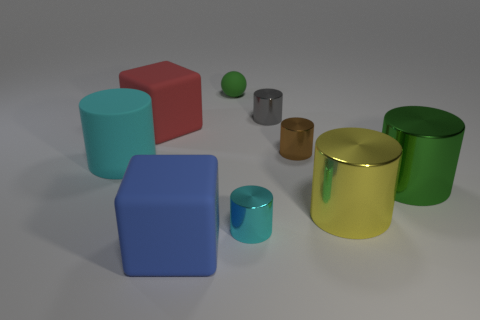Subtract all large green shiny cylinders. How many cylinders are left? 5 Subtract all red spheres. How many cyan cylinders are left? 2 Subtract all yellow cylinders. How many cylinders are left? 5 Add 1 gray objects. How many objects exist? 10 Subtract all brown cylinders. Subtract all purple spheres. How many cylinders are left? 5 Subtract all balls. How many objects are left? 8 Add 1 balls. How many balls are left? 2 Add 8 tiny green cubes. How many tiny green cubes exist? 8 Subtract 1 yellow cylinders. How many objects are left? 8 Subtract all large red rubber things. Subtract all big red rubber cubes. How many objects are left? 7 